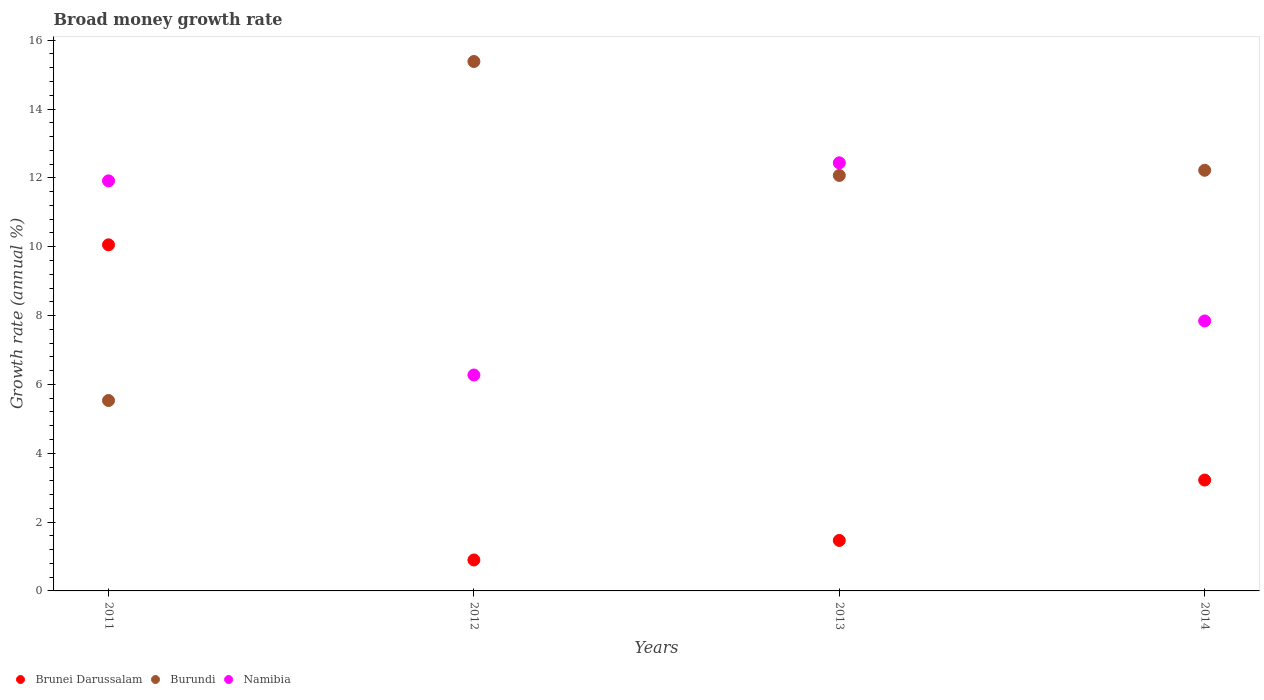How many different coloured dotlines are there?
Your answer should be compact. 3. What is the growth rate in Burundi in 2011?
Provide a succinct answer. 5.53. Across all years, what is the maximum growth rate in Brunei Darussalam?
Ensure brevity in your answer.  10.05. Across all years, what is the minimum growth rate in Brunei Darussalam?
Provide a short and direct response. 0.9. In which year was the growth rate in Brunei Darussalam minimum?
Ensure brevity in your answer.  2012. What is the total growth rate in Brunei Darussalam in the graph?
Make the answer very short. 15.64. What is the difference between the growth rate in Burundi in 2012 and that in 2013?
Offer a terse response. 3.31. What is the difference between the growth rate in Burundi in 2013 and the growth rate in Namibia in 2014?
Your response must be concise. 4.23. What is the average growth rate in Burundi per year?
Offer a very short reply. 11.3. In the year 2011, what is the difference between the growth rate in Namibia and growth rate in Brunei Darussalam?
Provide a succinct answer. 1.86. What is the ratio of the growth rate in Brunei Darussalam in 2012 to that in 2013?
Offer a very short reply. 0.61. Is the growth rate in Brunei Darussalam in 2012 less than that in 2013?
Provide a succinct answer. Yes. What is the difference between the highest and the second highest growth rate in Brunei Darussalam?
Provide a short and direct response. 6.83. What is the difference between the highest and the lowest growth rate in Namibia?
Offer a very short reply. 6.16. Is the sum of the growth rate in Burundi in 2012 and 2014 greater than the maximum growth rate in Brunei Darussalam across all years?
Provide a short and direct response. Yes. Is it the case that in every year, the sum of the growth rate in Namibia and growth rate in Burundi  is greater than the growth rate in Brunei Darussalam?
Offer a very short reply. Yes. Does the growth rate in Burundi monotonically increase over the years?
Offer a very short reply. No. Is the growth rate in Brunei Darussalam strictly greater than the growth rate in Burundi over the years?
Offer a very short reply. No. Is the growth rate in Burundi strictly less than the growth rate in Namibia over the years?
Your answer should be compact. No. How many years are there in the graph?
Ensure brevity in your answer.  4. Are the values on the major ticks of Y-axis written in scientific E-notation?
Ensure brevity in your answer.  No. Where does the legend appear in the graph?
Make the answer very short. Bottom left. How are the legend labels stacked?
Your response must be concise. Horizontal. What is the title of the graph?
Keep it short and to the point. Broad money growth rate. What is the label or title of the X-axis?
Keep it short and to the point. Years. What is the label or title of the Y-axis?
Ensure brevity in your answer.  Growth rate (annual %). What is the Growth rate (annual %) of Brunei Darussalam in 2011?
Provide a short and direct response. 10.05. What is the Growth rate (annual %) of Burundi in 2011?
Provide a short and direct response. 5.53. What is the Growth rate (annual %) of Namibia in 2011?
Offer a very short reply. 11.91. What is the Growth rate (annual %) in Brunei Darussalam in 2012?
Ensure brevity in your answer.  0.9. What is the Growth rate (annual %) in Burundi in 2012?
Offer a terse response. 15.38. What is the Growth rate (annual %) of Namibia in 2012?
Provide a short and direct response. 6.27. What is the Growth rate (annual %) of Brunei Darussalam in 2013?
Provide a short and direct response. 1.47. What is the Growth rate (annual %) in Burundi in 2013?
Keep it short and to the point. 12.07. What is the Growth rate (annual %) in Namibia in 2013?
Make the answer very short. 12.44. What is the Growth rate (annual %) of Brunei Darussalam in 2014?
Offer a terse response. 3.22. What is the Growth rate (annual %) of Burundi in 2014?
Offer a very short reply. 12.22. What is the Growth rate (annual %) in Namibia in 2014?
Give a very brief answer. 7.84. Across all years, what is the maximum Growth rate (annual %) of Brunei Darussalam?
Your response must be concise. 10.05. Across all years, what is the maximum Growth rate (annual %) of Burundi?
Offer a very short reply. 15.38. Across all years, what is the maximum Growth rate (annual %) in Namibia?
Give a very brief answer. 12.44. Across all years, what is the minimum Growth rate (annual %) of Brunei Darussalam?
Your answer should be very brief. 0.9. Across all years, what is the minimum Growth rate (annual %) of Burundi?
Ensure brevity in your answer.  5.53. Across all years, what is the minimum Growth rate (annual %) of Namibia?
Make the answer very short. 6.27. What is the total Growth rate (annual %) in Brunei Darussalam in the graph?
Give a very brief answer. 15.64. What is the total Growth rate (annual %) of Burundi in the graph?
Offer a terse response. 45.2. What is the total Growth rate (annual %) of Namibia in the graph?
Ensure brevity in your answer.  38.47. What is the difference between the Growth rate (annual %) in Brunei Darussalam in 2011 and that in 2012?
Your response must be concise. 9.16. What is the difference between the Growth rate (annual %) of Burundi in 2011 and that in 2012?
Offer a very short reply. -9.85. What is the difference between the Growth rate (annual %) of Namibia in 2011 and that in 2012?
Offer a very short reply. 5.64. What is the difference between the Growth rate (annual %) of Brunei Darussalam in 2011 and that in 2013?
Keep it short and to the point. 8.59. What is the difference between the Growth rate (annual %) of Burundi in 2011 and that in 2013?
Your answer should be compact. -6.54. What is the difference between the Growth rate (annual %) of Namibia in 2011 and that in 2013?
Offer a very short reply. -0.52. What is the difference between the Growth rate (annual %) of Brunei Darussalam in 2011 and that in 2014?
Your response must be concise. 6.83. What is the difference between the Growth rate (annual %) in Burundi in 2011 and that in 2014?
Give a very brief answer. -6.69. What is the difference between the Growth rate (annual %) in Namibia in 2011 and that in 2014?
Make the answer very short. 4.07. What is the difference between the Growth rate (annual %) of Brunei Darussalam in 2012 and that in 2013?
Your answer should be compact. -0.57. What is the difference between the Growth rate (annual %) in Burundi in 2012 and that in 2013?
Your response must be concise. 3.31. What is the difference between the Growth rate (annual %) in Namibia in 2012 and that in 2013?
Provide a short and direct response. -6.16. What is the difference between the Growth rate (annual %) in Brunei Darussalam in 2012 and that in 2014?
Make the answer very short. -2.32. What is the difference between the Growth rate (annual %) in Burundi in 2012 and that in 2014?
Give a very brief answer. 3.16. What is the difference between the Growth rate (annual %) of Namibia in 2012 and that in 2014?
Provide a succinct answer. -1.57. What is the difference between the Growth rate (annual %) of Brunei Darussalam in 2013 and that in 2014?
Your answer should be very brief. -1.75. What is the difference between the Growth rate (annual %) of Burundi in 2013 and that in 2014?
Offer a terse response. -0.15. What is the difference between the Growth rate (annual %) of Namibia in 2013 and that in 2014?
Make the answer very short. 4.59. What is the difference between the Growth rate (annual %) in Brunei Darussalam in 2011 and the Growth rate (annual %) in Burundi in 2012?
Offer a terse response. -5.33. What is the difference between the Growth rate (annual %) in Brunei Darussalam in 2011 and the Growth rate (annual %) in Namibia in 2012?
Provide a short and direct response. 3.78. What is the difference between the Growth rate (annual %) of Burundi in 2011 and the Growth rate (annual %) of Namibia in 2012?
Provide a short and direct response. -0.74. What is the difference between the Growth rate (annual %) of Brunei Darussalam in 2011 and the Growth rate (annual %) of Burundi in 2013?
Your response must be concise. -2.02. What is the difference between the Growth rate (annual %) of Brunei Darussalam in 2011 and the Growth rate (annual %) of Namibia in 2013?
Make the answer very short. -2.38. What is the difference between the Growth rate (annual %) in Burundi in 2011 and the Growth rate (annual %) in Namibia in 2013?
Ensure brevity in your answer.  -6.91. What is the difference between the Growth rate (annual %) of Brunei Darussalam in 2011 and the Growth rate (annual %) of Burundi in 2014?
Your answer should be compact. -2.17. What is the difference between the Growth rate (annual %) in Brunei Darussalam in 2011 and the Growth rate (annual %) in Namibia in 2014?
Your response must be concise. 2.21. What is the difference between the Growth rate (annual %) of Burundi in 2011 and the Growth rate (annual %) of Namibia in 2014?
Offer a terse response. -2.31. What is the difference between the Growth rate (annual %) of Brunei Darussalam in 2012 and the Growth rate (annual %) of Burundi in 2013?
Make the answer very short. -11.17. What is the difference between the Growth rate (annual %) in Brunei Darussalam in 2012 and the Growth rate (annual %) in Namibia in 2013?
Make the answer very short. -11.54. What is the difference between the Growth rate (annual %) of Burundi in 2012 and the Growth rate (annual %) of Namibia in 2013?
Keep it short and to the point. 2.94. What is the difference between the Growth rate (annual %) of Brunei Darussalam in 2012 and the Growth rate (annual %) of Burundi in 2014?
Offer a very short reply. -11.32. What is the difference between the Growth rate (annual %) of Brunei Darussalam in 2012 and the Growth rate (annual %) of Namibia in 2014?
Provide a succinct answer. -6.94. What is the difference between the Growth rate (annual %) of Burundi in 2012 and the Growth rate (annual %) of Namibia in 2014?
Keep it short and to the point. 7.54. What is the difference between the Growth rate (annual %) in Brunei Darussalam in 2013 and the Growth rate (annual %) in Burundi in 2014?
Provide a short and direct response. -10.75. What is the difference between the Growth rate (annual %) in Brunei Darussalam in 2013 and the Growth rate (annual %) in Namibia in 2014?
Offer a terse response. -6.38. What is the difference between the Growth rate (annual %) of Burundi in 2013 and the Growth rate (annual %) of Namibia in 2014?
Keep it short and to the point. 4.23. What is the average Growth rate (annual %) in Brunei Darussalam per year?
Make the answer very short. 3.91. What is the average Growth rate (annual %) in Burundi per year?
Offer a terse response. 11.3. What is the average Growth rate (annual %) of Namibia per year?
Make the answer very short. 9.62. In the year 2011, what is the difference between the Growth rate (annual %) in Brunei Darussalam and Growth rate (annual %) in Burundi?
Your answer should be very brief. 4.52. In the year 2011, what is the difference between the Growth rate (annual %) of Brunei Darussalam and Growth rate (annual %) of Namibia?
Provide a succinct answer. -1.86. In the year 2011, what is the difference between the Growth rate (annual %) of Burundi and Growth rate (annual %) of Namibia?
Make the answer very short. -6.38. In the year 2012, what is the difference between the Growth rate (annual %) of Brunei Darussalam and Growth rate (annual %) of Burundi?
Keep it short and to the point. -14.48. In the year 2012, what is the difference between the Growth rate (annual %) in Brunei Darussalam and Growth rate (annual %) in Namibia?
Offer a very short reply. -5.37. In the year 2012, what is the difference between the Growth rate (annual %) in Burundi and Growth rate (annual %) in Namibia?
Offer a very short reply. 9.11. In the year 2013, what is the difference between the Growth rate (annual %) in Brunei Darussalam and Growth rate (annual %) in Burundi?
Ensure brevity in your answer.  -10.6. In the year 2013, what is the difference between the Growth rate (annual %) in Brunei Darussalam and Growth rate (annual %) in Namibia?
Make the answer very short. -10.97. In the year 2013, what is the difference between the Growth rate (annual %) of Burundi and Growth rate (annual %) of Namibia?
Your answer should be compact. -0.37. In the year 2014, what is the difference between the Growth rate (annual %) of Brunei Darussalam and Growth rate (annual %) of Burundi?
Your response must be concise. -9. In the year 2014, what is the difference between the Growth rate (annual %) of Brunei Darussalam and Growth rate (annual %) of Namibia?
Give a very brief answer. -4.62. In the year 2014, what is the difference between the Growth rate (annual %) of Burundi and Growth rate (annual %) of Namibia?
Provide a succinct answer. 4.38. What is the ratio of the Growth rate (annual %) of Brunei Darussalam in 2011 to that in 2012?
Ensure brevity in your answer.  11.18. What is the ratio of the Growth rate (annual %) in Burundi in 2011 to that in 2012?
Your answer should be very brief. 0.36. What is the ratio of the Growth rate (annual %) in Namibia in 2011 to that in 2012?
Provide a short and direct response. 1.9. What is the ratio of the Growth rate (annual %) in Brunei Darussalam in 2011 to that in 2013?
Provide a short and direct response. 6.86. What is the ratio of the Growth rate (annual %) of Burundi in 2011 to that in 2013?
Your answer should be compact. 0.46. What is the ratio of the Growth rate (annual %) in Namibia in 2011 to that in 2013?
Ensure brevity in your answer.  0.96. What is the ratio of the Growth rate (annual %) in Brunei Darussalam in 2011 to that in 2014?
Keep it short and to the point. 3.12. What is the ratio of the Growth rate (annual %) in Burundi in 2011 to that in 2014?
Keep it short and to the point. 0.45. What is the ratio of the Growth rate (annual %) of Namibia in 2011 to that in 2014?
Offer a terse response. 1.52. What is the ratio of the Growth rate (annual %) of Brunei Darussalam in 2012 to that in 2013?
Your answer should be compact. 0.61. What is the ratio of the Growth rate (annual %) of Burundi in 2012 to that in 2013?
Offer a very short reply. 1.27. What is the ratio of the Growth rate (annual %) in Namibia in 2012 to that in 2013?
Keep it short and to the point. 0.5. What is the ratio of the Growth rate (annual %) of Brunei Darussalam in 2012 to that in 2014?
Your answer should be very brief. 0.28. What is the ratio of the Growth rate (annual %) in Burundi in 2012 to that in 2014?
Offer a terse response. 1.26. What is the ratio of the Growth rate (annual %) of Namibia in 2012 to that in 2014?
Give a very brief answer. 0.8. What is the ratio of the Growth rate (annual %) of Brunei Darussalam in 2013 to that in 2014?
Keep it short and to the point. 0.46. What is the ratio of the Growth rate (annual %) in Namibia in 2013 to that in 2014?
Keep it short and to the point. 1.59. What is the difference between the highest and the second highest Growth rate (annual %) of Brunei Darussalam?
Make the answer very short. 6.83. What is the difference between the highest and the second highest Growth rate (annual %) of Burundi?
Your answer should be very brief. 3.16. What is the difference between the highest and the second highest Growth rate (annual %) in Namibia?
Ensure brevity in your answer.  0.52. What is the difference between the highest and the lowest Growth rate (annual %) in Brunei Darussalam?
Offer a very short reply. 9.16. What is the difference between the highest and the lowest Growth rate (annual %) in Burundi?
Offer a terse response. 9.85. What is the difference between the highest and the lowest Growth rate (annual %) of Namibia?
Offer a very short reply. 6.16. 